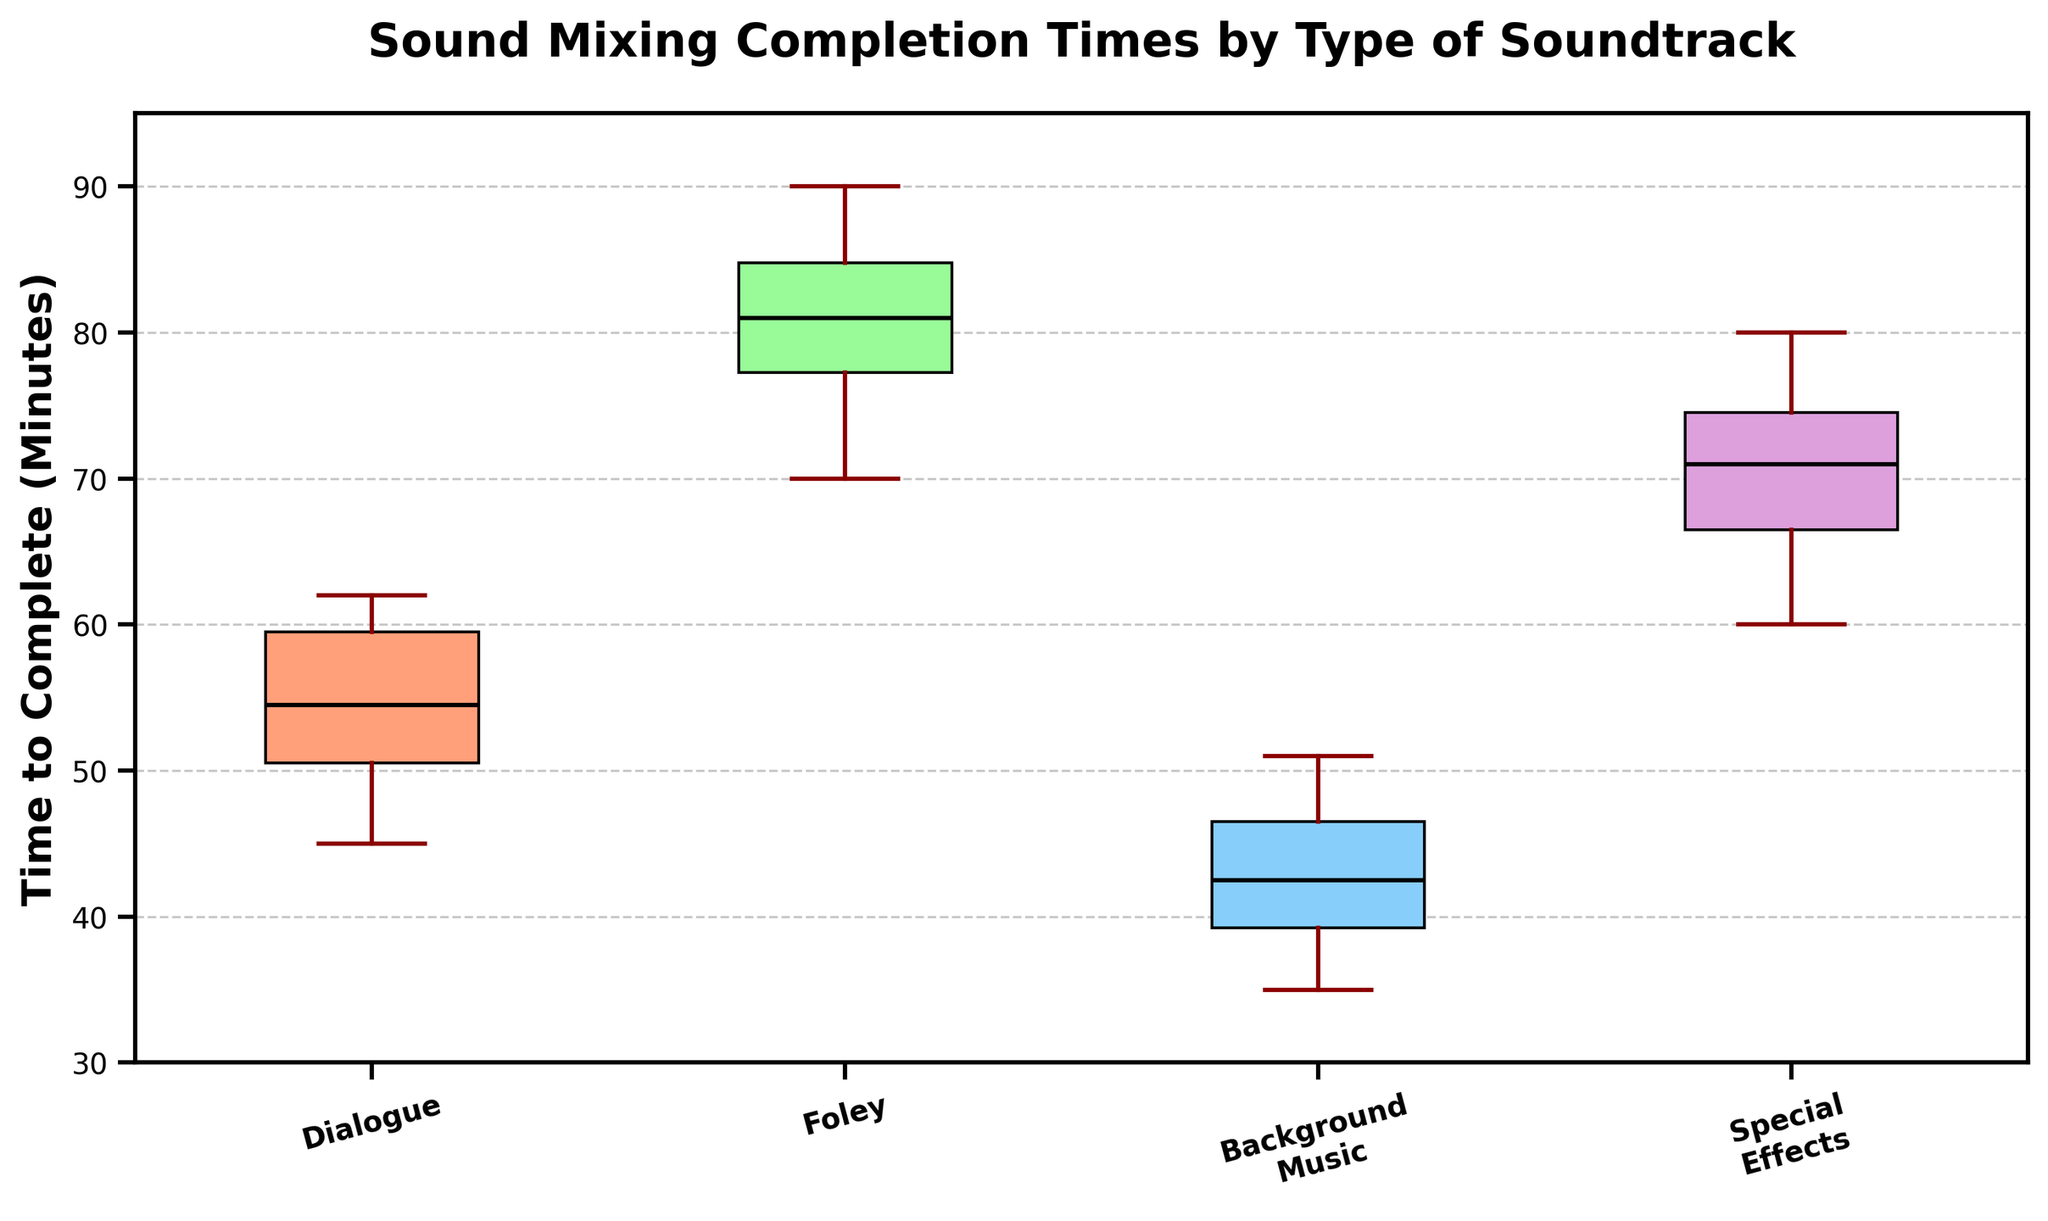What is the title of the figure? The title is usually at the top of the figure in a bold, large font. It summarizes what the figure is about.
Answer: Sound Mixing Completion Times by Type of Soundtrack How many types of soundtracks are represented in the figure? The types of soundtracks correspond to the labels on the x-axis. Count the distinct labels.
Answer: Four Which type of soundtrack has the longest median completion time? The median completion time is represented by the line in the middle of each box. Compare the median lines of each box.
Answer: Foley What is the interquartile range (IQR) for Dialogue's completion times? The IQR is the difference between the third quartile (top of the box) and the first quartile (bottom of the box) values for Dialogue.
Answer: 9 Which type of soundtrack has the smallest range in completion times? The range is the difference between the top whisker (maximum) and the bottom whisker (minimum) of each box plot. Identify the smallest range.
Answer: Background Music What colors are used in the box plot for each soundtrack type? Colors can be observed in the boxes in the plot. Identify and list the colors corresponding to each soundtrack type.
Answer: Dialogue: salmon, Foley: green, Background Music: sky blue, Special Effects: light purple Which soundtrack type has the highest upper quartile value? The upper quartile is the top edge of the box. Compare the top edges of all boxes to find the highest one.
Answer: Foley What are the median completion times for all soundtrack types? Medians are depicted by the lines inside the boxes. Note the median values for each type.
Answer: Dialogue: 55, Foley: 82, Background Music: 42, Special Effects: 72 Which soundtrack types have their lower whiskers (minimum values) below 40 minutes? The lower whisker represents the minimum value. Check the lower whiskers for each type and see which are below 40 minutes.
Answer: Background Music From the figure, which soundtrack type shows the most variability in completion times? Variability can be assessed by looking at the range between the whiskers and the spread of the data within each box. The one with the largest spread indicates the most variability.
Answer: Foley 